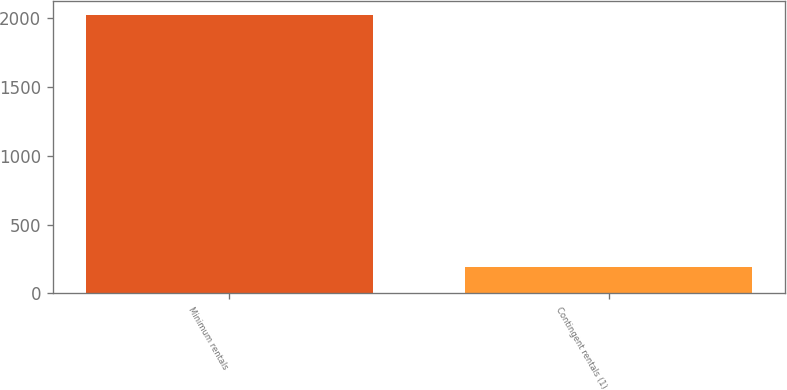<chart> <loc_0><loc_0><loc_500><loc_500><bar_chart><fcel>Minimum rentals<fcel>Contingent rentals (1)<nl><fcel>2025<fcel>193<nl></chart> 